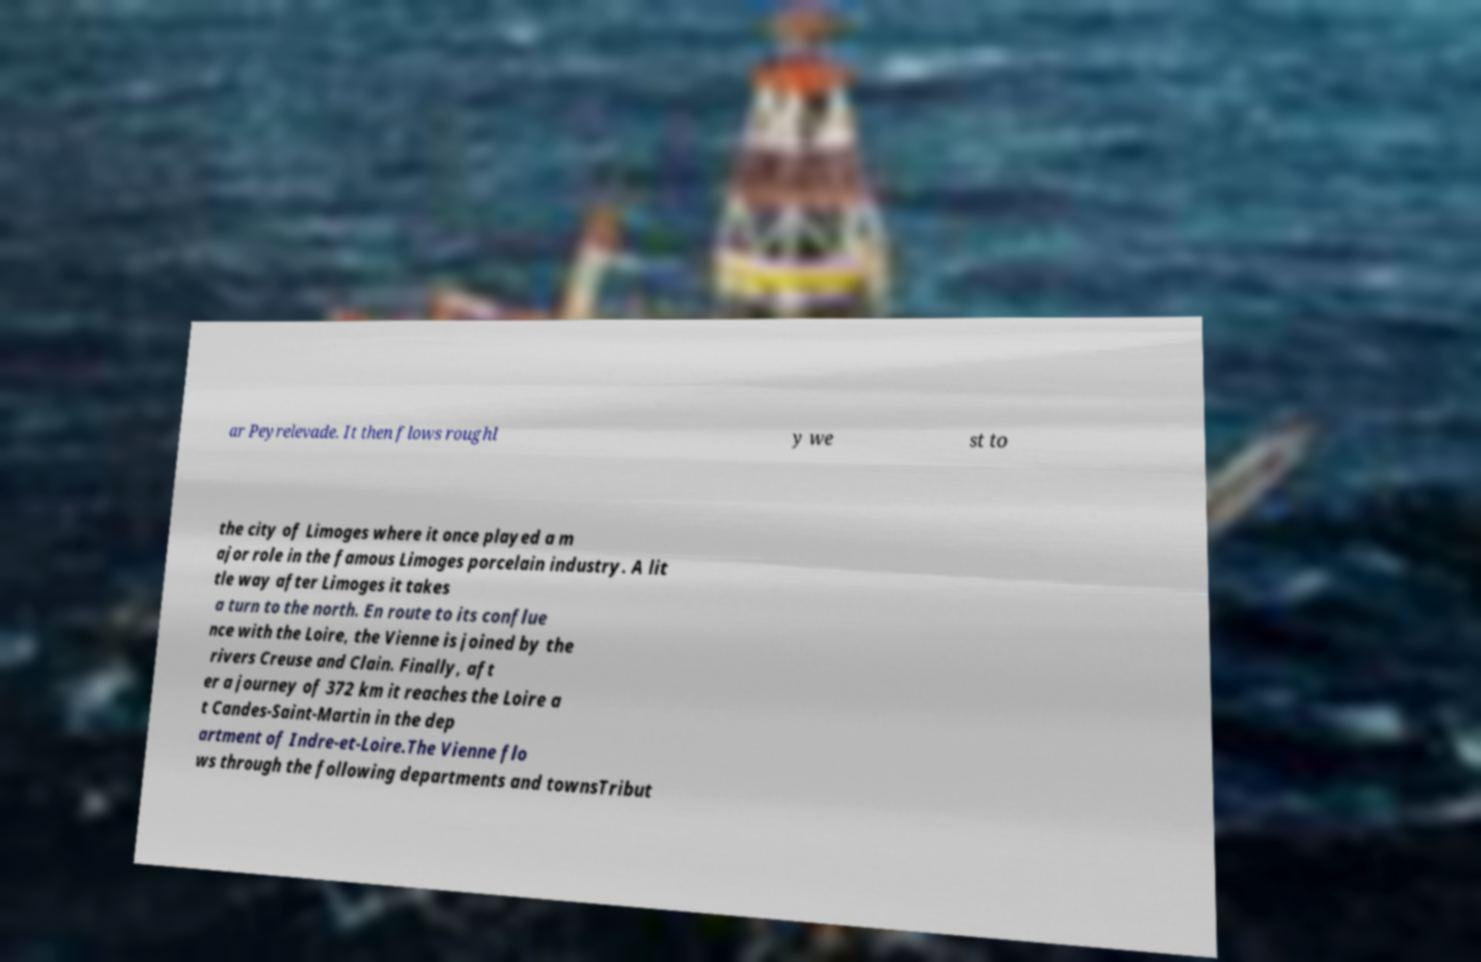Can you read and provide the text displayed in the image?This photo seems to have some interesting text. Can you extract and type it out for me? ar Peyrelevade. It then flows roughl y we st to the city of Limoges where it once played a m ajor role in the famous Limoges porcelain industry. A lit tle way after Limoges it takes a turn to the north. En route to its conflue nce with the Loire, the Vienne is joined by the rivers Creuse and Clain. Finally, aft er a journey of 372 km it reaches the Loire a t Candes-Saint-Martin in the dep artment of Indre-et-Loire.The Vienne flo ws through the following departments and townsTribut 